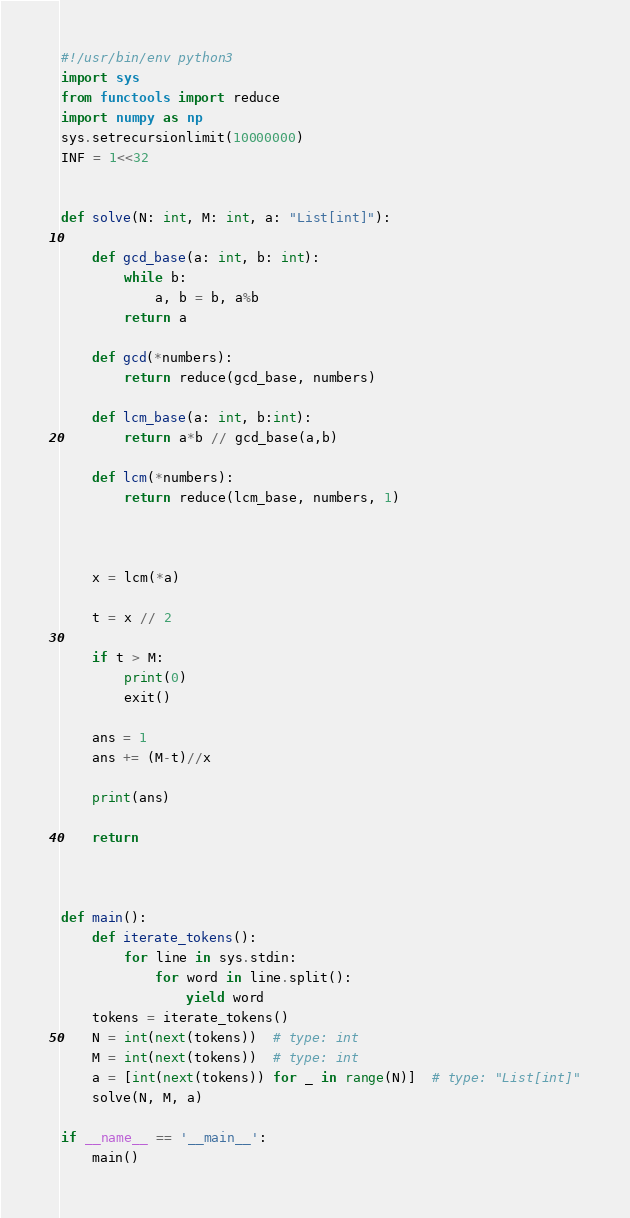<code> <loc_0><loc_0><loc_500><loc_500><_Python_>#!/usr/bin/env python3
import sys
from functools import reduce
import numpy as np
sys.setrecursionlimit(10000000)
INF = 1<<32


def solve(N: int, M: int, a: "List[int]"):

    def gcd_base(a: int, b: int):
        while b:
            a, b = b, a%b
        return a

    def gcd(*numbers):
        return reduce(gcd_base, numbers)
    
    def lcm_base(a: int, b:int):
        return a*b // gcd_base(a,b)

    def lcm(*numbers):
        return reduce(lcm_base, numbers, 1)



    x = lcm(*a)

    t = x // 2

    if t > M:
        print(0)
        exit()

    ans = 1
    ans += (M-t)//x
    
    print(ans)

    return



def main():
    def iterate_tokens():
        for line in sys.stdin:
            for word in line.split():
                yield word
    tokens = iterate_tokens()
    N = int(next(tokens))  # type: int
    M = int(next(tokens))  # type: int
    a = [int(next(tokens)) for _ in range(N)]  # type: "List[int]"
    solve(N, M, a)

if __name__ == '__main__':
    main()
</code> 